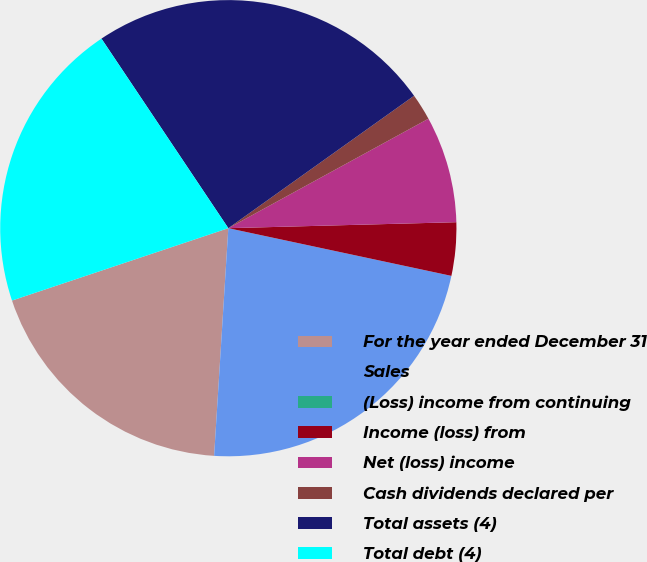<chart> <loc_0><loc_0><loc_500><loc_500><pie_chart><fcel>For the year ended December 31<fcel>Sales<fcel>(Loss) income from continuing<fcel>Income (loss) from<fcel>Net (loss) income<fcel>Cash dividends declared per<fcel>Total assets (4)<fcel>Total debt (4)<nl><fcel>18.87%<fcel>22.64%<fcel>0.0%<fcel>3.77%<fcel>7.55%<fcel>1.89%<fcel>24.53%<fcel>20.75%<nl></chart> 